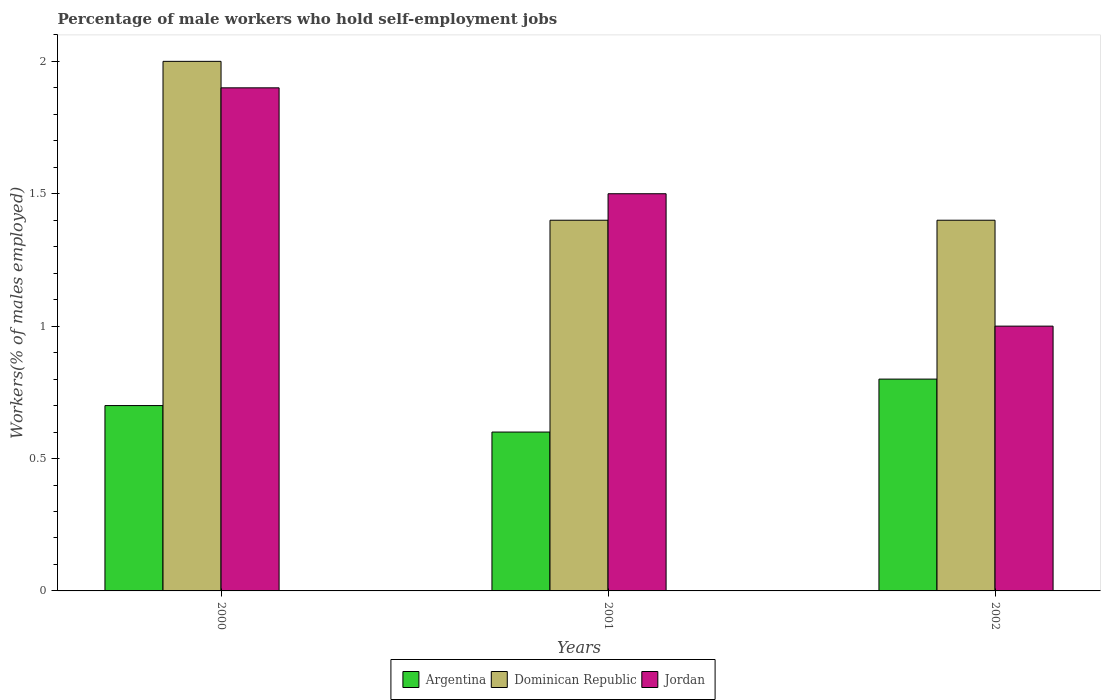How many groups of bars are there?
Give a very brief answer. 3. What is the label of the 2nd group of bars from the left?
Ensure brevity in your answer.  2001. What is the percentage of self-employed male workers in Dominican Republic in 2001?
Provide a succinct answer. 1.4. Across all years, what is the maximum percentage of self-employed male workers in Argentina?
Offer a terse response. 0.8. Across all years, what is the minimum percentage of self-employed male workers in Dominican Republic?
Ensure brevity in your answer.  1.4. In which year was the percentage of self-employed male workers in Argentina minimum?
Provide a succinct answer. 2001. What is the total percentage of self-employed male workers in Dominican Republic in the graph?
Ensure brevity in your answer.  4.8. What is the difference between the percentage of self-employed male workers in Dominican Republic in 2000 and that in 2002?
Ensure brevity in your answer.  0.6. What is the average percentage of self-employed male workers in Argentina per year?
Offer a very short reply. 0.7. In the year 2000, what is the difference between the percentage of self-employed male workers in Dominican Republic and percentage of self-employed male workers in Argentina?
Make the answer very short. 1.3. In how many years, is the percentage of self-employed male workers in Argentina greater than 1.7 %?
Your response must be concise. 0. What is the ratio of the percentage of self-employed male workers in Jordan in 2000 to that in 2001?
Provide a succinct answer. 1.27. Is the percentage of self-employed male workers in Jordan in 2000 less than that in 2001?
Offer a very short reply. No. Is the difference between the percentage of self-employed male workers in Dominican Republic in 2000 and 2001 greater than the difference between the percentage of self-employed male workers in Argentina in 2000 and 2001?
Offer a very short reply. Yes. What is the difference between the highest and the second highest percentage of self-employed male workers in Dominican Republic?
Keep it short and to the point. 0.6. What is the difference between the highest and the lowest percentage of self-employed male workers in Jordan?
Your response must be concise. 0.9. What does the 1st bar from the left in 2002 represents?
Your answer should be very brief. Argentina. What does the 2nd bar from the right in 2000 represents?
Offer a terse response. Dominican Republic. Are all the bars in the graph horizontal?
Ensure brevity in your answer.  No. How many years are there in the graph?
Provide a succinct answer. 3. Does the graph contain grids?
Provide a succinct answer. No. Where does the legend appear in the graph?
Provide a succinct answer. Bottom center. What is the title of the graph?
Provide a succinct answer. Percentage of male workers who hold self-employment jobs. What is the label or title of the Y-axis?
Your response must be concise. Workers(% of males employed). What is the Workers(% of males employed) of Argentina in 2000?
Provide a succinct answer. 0.7. What is the Workers(% of males employed) in Jordan in 2000?
Keep it short and to the point. 1.9. What is the Workers(% of males employed) in Argentina in 2001?
Offer a very short reply. 0.6. What is the Workers(% of males employed) in Dominican Republic in 2001?
Provide a short and direct response. 1.4. What is the Workers(% of males employed) of Jordan in 2001?
Your answer should be very brief. 1.5. What is the Workers(% of males employed) of Argentina in 2002?
Ensure brevity in your answer.  0.8. What is the Workers(% of males employed) of Dominican Republic in 2002?
Keep it short and to the point. 1.4. What is the Workers(% of males employed) in Jordan in 2002?
Provide a succinct answer. 1. Across all years, what is the maximum Workers(% of males employed) of Argentina?
Keep it short and to the point. 0.8. Across all years, what is the maximum Workers(% of males employed) in Dominican Republic?
Your answer should be compact. 2. Across all years, what is the maximum Workers(% of males employed) of Jordan?
Keep it short and to the point. 1.9. Across all years, what is the minimum Workers(% of males employed) of Argentina?
Make the answer very short. 0.6. Across all years, what is the minimum Workers(% of males employed) in Dominican Republic?
Keep it short and to the point. 1.4. Across all years, what is the minimum Workers(% of males employed) in Jordan?
Offer a terse response. 1. What is the total Workers(% of males employed) in Argentina in the graph?
Your answer should be very brief. 2.1. What is the difference between the Workers(% of males employed) of Dominican Republic in 2000 and that in 2001?
Make the answer very short. 0.6. What is the difference between the Workers(% of males employed) in Jordan in 2000 and that in 2001?
Give a very brief answer. 0.4. What is the difference between the Workers(% of males employed) of Dominican Republic in 2000 and that in 2002?
Your response must be concise. 0.6. What is the difference between the Workers(% of males employed) in Jordan in 2000 and that in 2002?
Provide a succinct answer. 0.9. What is the difference between the Workers(% of males employed) of Dominican Republic in 2001 and that in 2002?
Offer a terse response. 0. What is the difference between the Workers(% of males employed) of Argentina in 2000 and the Workers(% of males employed) of Jordan in 2001?
Your answer should be compact. -0.8. What is the difference between the Workers(% of males employed) of Dominican Republic in 2000 and the Workers(% of males employed) of Jordan in 2001?
Make the answer very short. 0.5. What is the difference between the Workers(% of males employed) of Argentina in 2000 and the Workers(% of males employed) of Dominican Republic in 2002?
Give a very brief answer. -0.7. What is the difference between the Workers(% of males employed) in Dominican Republic in 2000 and the Workers(% of males employed) in Jordan in 2002?
Keep it short and to the point. 1. What is the difference between the Workers(% of males employed) in Dominican Republic in 2001 and the Workers(% of males employed) in Jordan in 2002?
Give a very brief answer. 0.4. What is the average Workers(% of males employed) of Argentina per year?
Offer a very short reply. 0.7. What is the average Workers(% of males employed) of Jordan per year?
Your response must be concise. 1.47. In the year 2001, what is the difference between the Workers(% of males employed) in Dominican Republic and Workers(% of males employed) in Jordan?
Ensure brevity in your answer.  -0.1. What is the ratio of the Workers(% of males employed) of Argentina in 2000 to that in 2001?
Offer a terse response. 1.17. What is the ratio of the Workers(% of males employed) in Dominican Republic in 2000 to that in 2001?
Ensure brevity in your answer.  1.43. What is the ratio of the Workers(% of males employed) in Jordan in 2000 to that in 2001?
Keep it short and to the point. 1.27. What is the ratio of the Workers(% of males employed) in Argentina in 2000 to that in 2002?
Offer a terse response. 0.88. What is the ratio of the Workers(% of males employed) in Dominican Republic in 2000 to that in 2002?
Your response must be concise. 1.43. What is the ratio of the Workers(% of males employed) in Jordan in 2000 to that in 2002?
Keep it short and to the point. 1.9. What is the ratio of the Workers(% of males employed) of Jordan in 2001 to that in 2002?
Your answer should be compact. 1.5. What is the difference between the highest and the second highest Workers(% of males employed) of Jordan?
Provide a succinct answer. 0.4. What is the difference between the highest and the lowest Workers(% of males employed) of Jordan?
Make the answer very short. 0.9. 